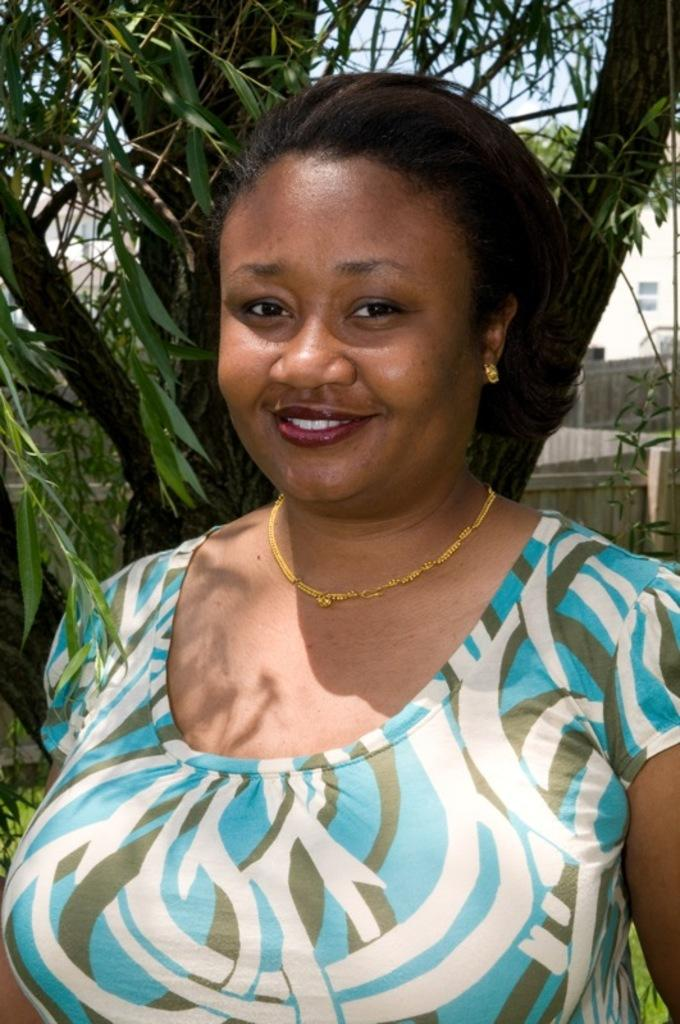Who is the main subject in the image? There is a woman in the image. What is the woman wearing? The woman is wearing a blue t-shirt and a gold chain. What is the background of the image? The woman is standing in front of a tree. How is the woman feeling in the image? The woman is smiling at someone, which suggests she is feeling happy or friendly. What type of plants can be seen growing on the woman's head in the image? There are no plants visible on the woman's head in the image. 